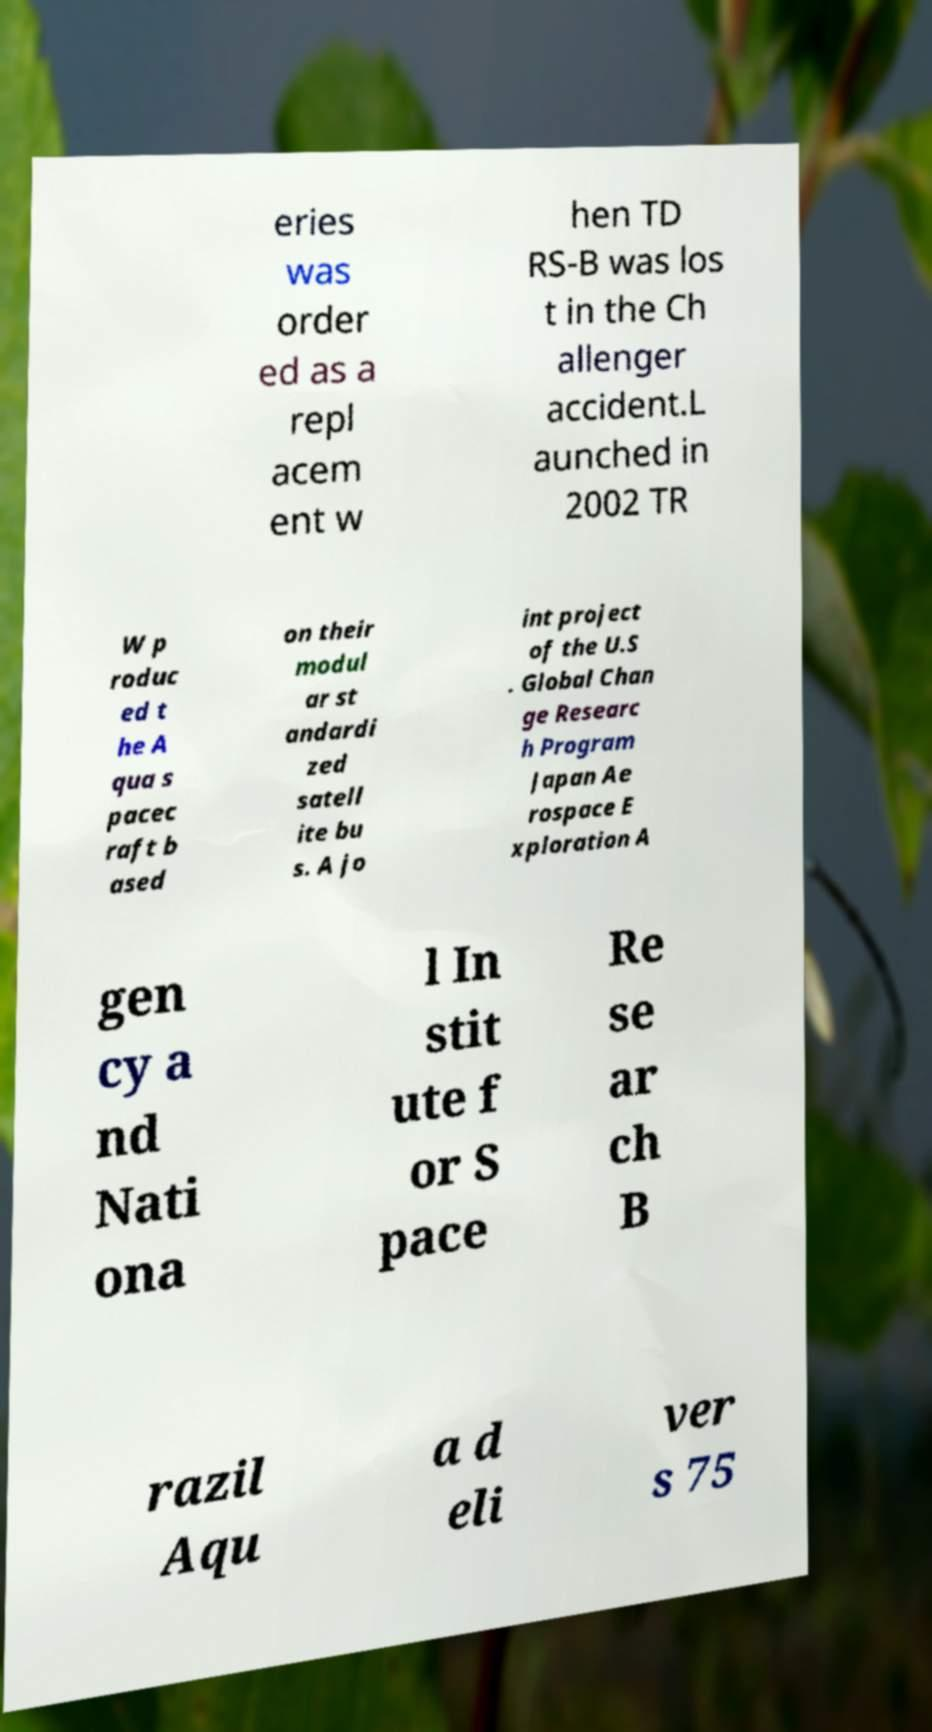I need the written content from this picture converted into text. Can you do that? eries was order ed as a repl acem ent w hen TD RS-B was los t in the Ch allenger accident.L aunched in 2002 TR W p roduc ed t he A qua s pacec raft b ased on their modul ar st andardi zed satell ite bu s. A jo int project of the U.S . Global Chan ge Researc h Program Japan Ae rospace E xploration A gen cy a nd Nati ona l In stit ute f or S pace Re se ar ch B razil Aqu a d eli ver s 75 